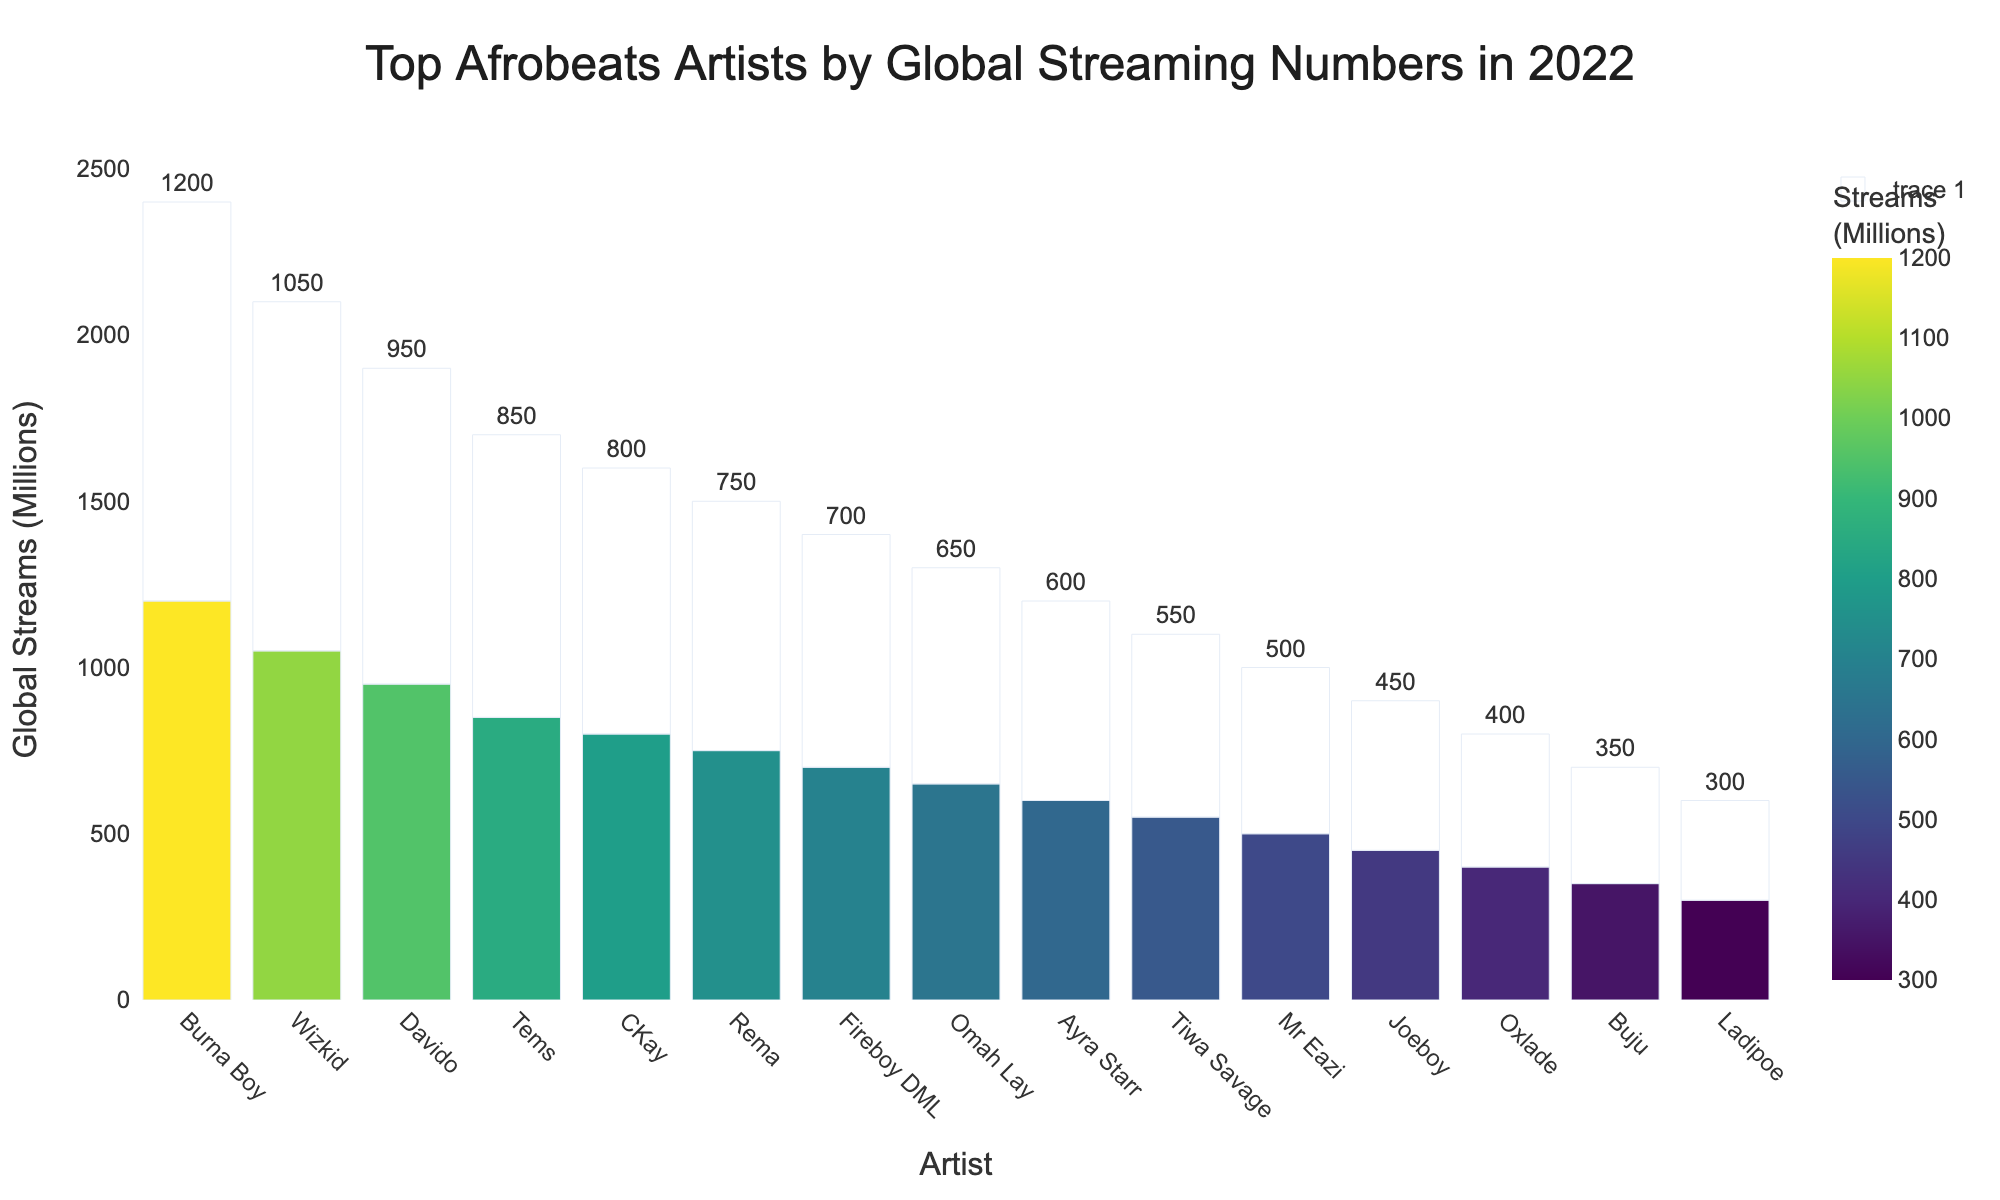Which artist has the highest global streams in 2022? Look at the chart and identify the tallest bar, which corresponds to the highest global streams. The artist with the highest bar is Burna Boy.
Answer: Burna Boy How many artists have over 1000 million global streams? Observe the chart and count the bars that represent global streams greater than 1000 million. Only Burna Boy and Wizkid have streams over 1000 million.
Answer: 2 What is the difference in global streams between the top artist and the artist with the least streams? Find the global streams for the top artist (Burna Boy) and the artist with the least streams (Ladipoe). Burna Boy has 1200 million streams and Ladipoe has 300 million, so the difference is 1200 - 300 = 900 million streams.
Answer: 900 million Who are the three artists with the lowest global streams, and what are their stream counts? Look at the chart and find the three bars with the lowest heights. These artists are Ladipoe (300 million), Buju (350 million), and Oxlade (400 million).
Answer: Ladipoe, Buju, Oxlade with 300 million, 350 million, and 400 million streams respectively What's the average global streams of the top 5 artists? Identify the global streams of the top 5 artists: Burna Boy (1200 million), Wizkid (1050 million), Davido (950 million), Tems (850 million), CKay (800 million). Sum these values and divide by 5: (1200 + 1050 + 950 + 850 + 800) / 5 = 970 million streams.
Answer: 970 million Which artists have global streams between 700 million and 800 million? Identify the bars that fall within the range of 700 million to 800 million streams. These artists are Rema (750 million) and Fireboy DML (700 million).
Answer: Rema and Fireboy DML How many artists have global streams less than 600 million? Count the number of bars that represent less than 600 million global streams. The artists are Tiwa Savage, Mr Eazi, Joeboy, Oxlade, Buju, and Ladipoe, which makes 6 artists in total.
Answer: 6 By how much do the global streams of the top 2 artists differ from each other? Find the difference between the global streams of Burna Boy (1200 million) and Wizkid (1050 million). The difference is 1200 - 1050 = 150 million streams.
Answer: 150 million Which artist has the median global streaming value? Arrange the global streams in ascending order and find the middle value. The ordered list is: Ladipoe (300), Buju (350), Oxlade (400), Joeboy (450), Mr Eazi (500), Tiwa Savage (550), Ayra Starr (600), Omah Lay (650), Fireboy DML (700), Rema (750), CKay (800), Tems (850), Davido (950), Wizkid (1050), Burna Boy (1200). The median value falls in the middle at Ayra Starr with 600 million streams.
Answer: Ayra Starr How many total global streams are represented by the artists in the chart? Sum all the global streams listed: 1200 + 1050 + 950 + 850 + 800 + 750 + 700 + 650 + 600 + 550 + 500 + 450 + 400 + 350 + 300 = 10100 million streams.
Answer: 10100 million 